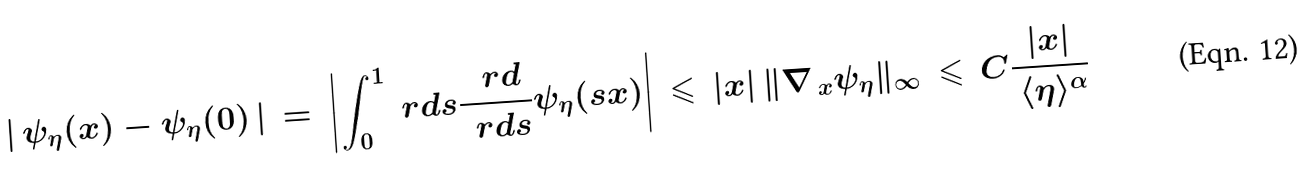<formula> <loc_0><loc_0><loc_500><loc_500>\left | \, \psi _ { \eta } ( x ) - \psi _ { \eta } ( 0 ) \, \right | \, & = \, \left | \int _ { 0 } ^ { 1 } \ r d s \frac { \, \ r d } { \, \ r d s } \psi _ { \eta } ( s x ) \right | \, \leqslant \, | x | \, \| \nabla _ { \, x } \psi _ { \eta } \| _ { \infty } \, \leqslant \, C \frac { | x | } { \, \langle \eta \rangle ^ { \alpha } }</formula> 